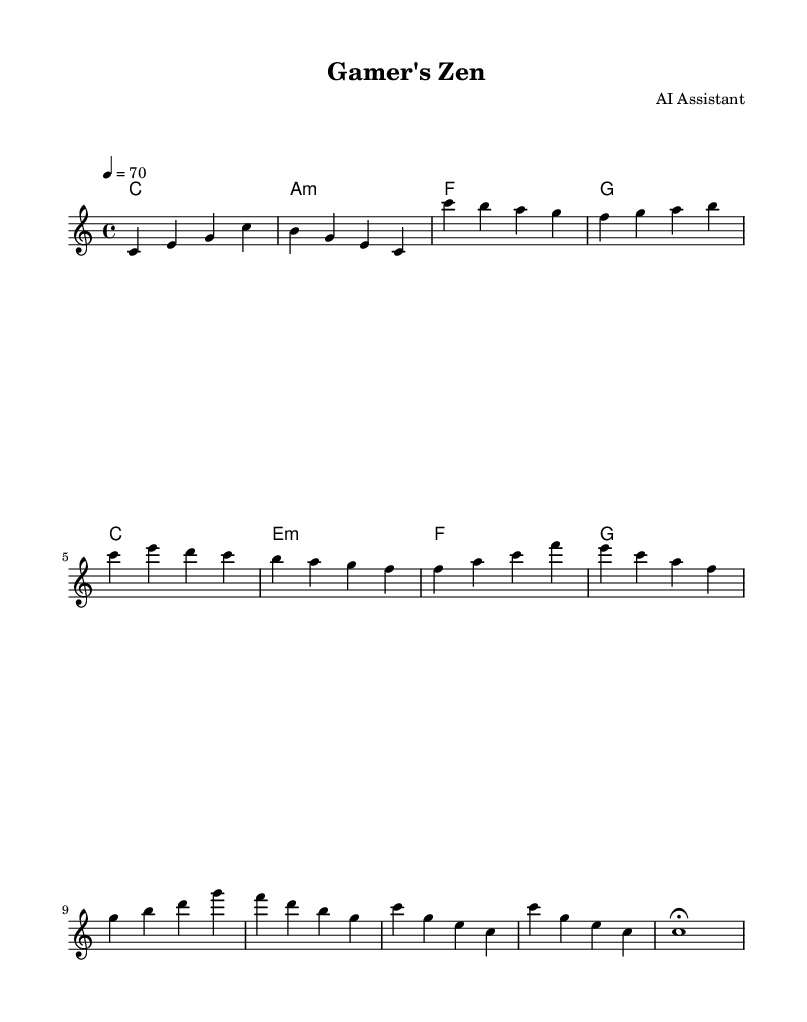What is the key signature of this music? The key signature shows no sharps or flats, indicating it is in C major.
Answer: C major What is the time signature of this music? The time signature is indicated at the beginning of the score, which is 4/4, meaning there are four beats in each measure.
Answer: 4/4 What is the tempo marking for this piece? The tempo is specified as 4 = 70, meaning there are 70 beats per minute, providing a moderate speed.
Answer: 70 How many measures are in the melody section? By counting the measures in the melody line, there are 12 measures total in this section.
Answer: 12 What is the last note of the melody section? The last note in the melody is shown as a whole note, which is C, and it is marked with a fermata indicating it should be held longer.
Answer: C What type of chords are mainly used in this piece? The chord progression primarily consists of major and minor chords, which can be identified in the chord section as C, A minor, F, and G chords.
Answer: Major and minor How does the bridge section evolve musically compared to the main theme? The bridge section introduces new chords and a different melody contour, thus creating contrast while still maintaining a calm atmosphere.
Answer: Contrast in chords and melody 